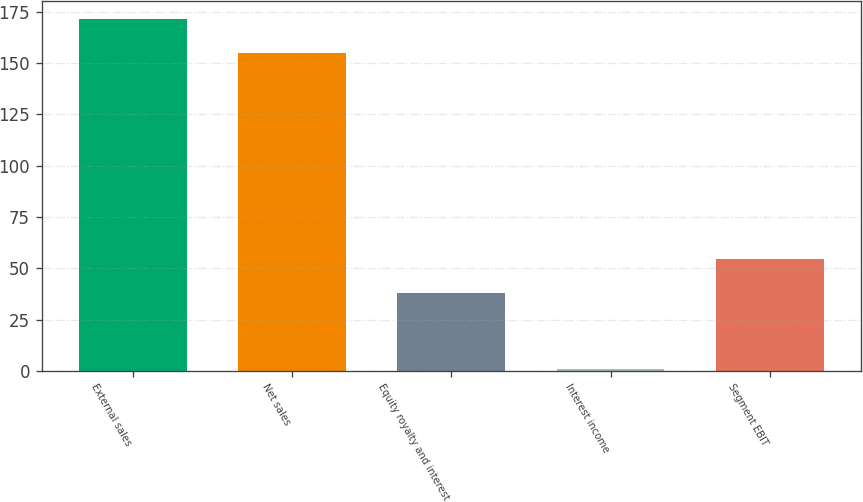Convert chart to OTSL. <chart><loc_0><loc_0><loc_500><loc_500><bar_chart><fcel>External sales<fcel>Net sales<fcel>Equity royalty and interest<fcel>Interest income<fcel>Segment EBIT<nl><fcel>171.7<fcel>155<fcel>38<fcel>1<fcel>54.7<nl></chart> 